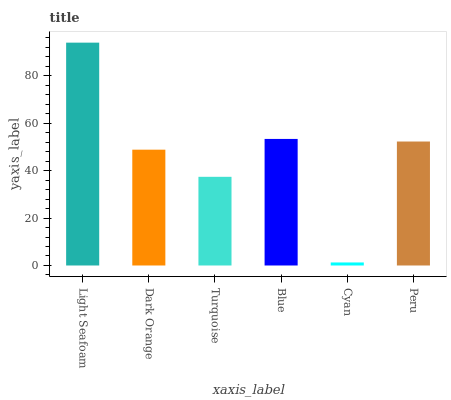Is Dark Orange the minimum?
Answer yes or no. No. Is Dark Orange the maximum?
Answer yes or no. No. Is Light Seafoam greater than Dark Orange?
Answer yes or no. Yes. Is Dark Orange less than Light Seafoam?
Answer yes or no. Yes. Is Dark Orange greater than Light Seafoam?
Answer yes or no. No. Is Light Seafoam less than Dark Orange?
Answer yes or no. No. Is Peru the high median?
Answer yes or no. Yes. Is Dark Orange the low median?
Answer yes or no. Yes. Is Blue the high median?
Answer yes or no. No. Is Blue the low median?
Answer yes or no. No. 